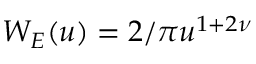Convert formula to latex. <formula><loc_0><loc_0><loc_500><loc_500>W _ { E } ( u ) = 2 / \pi u ^ { 1 + 2 \nu }</formula> 